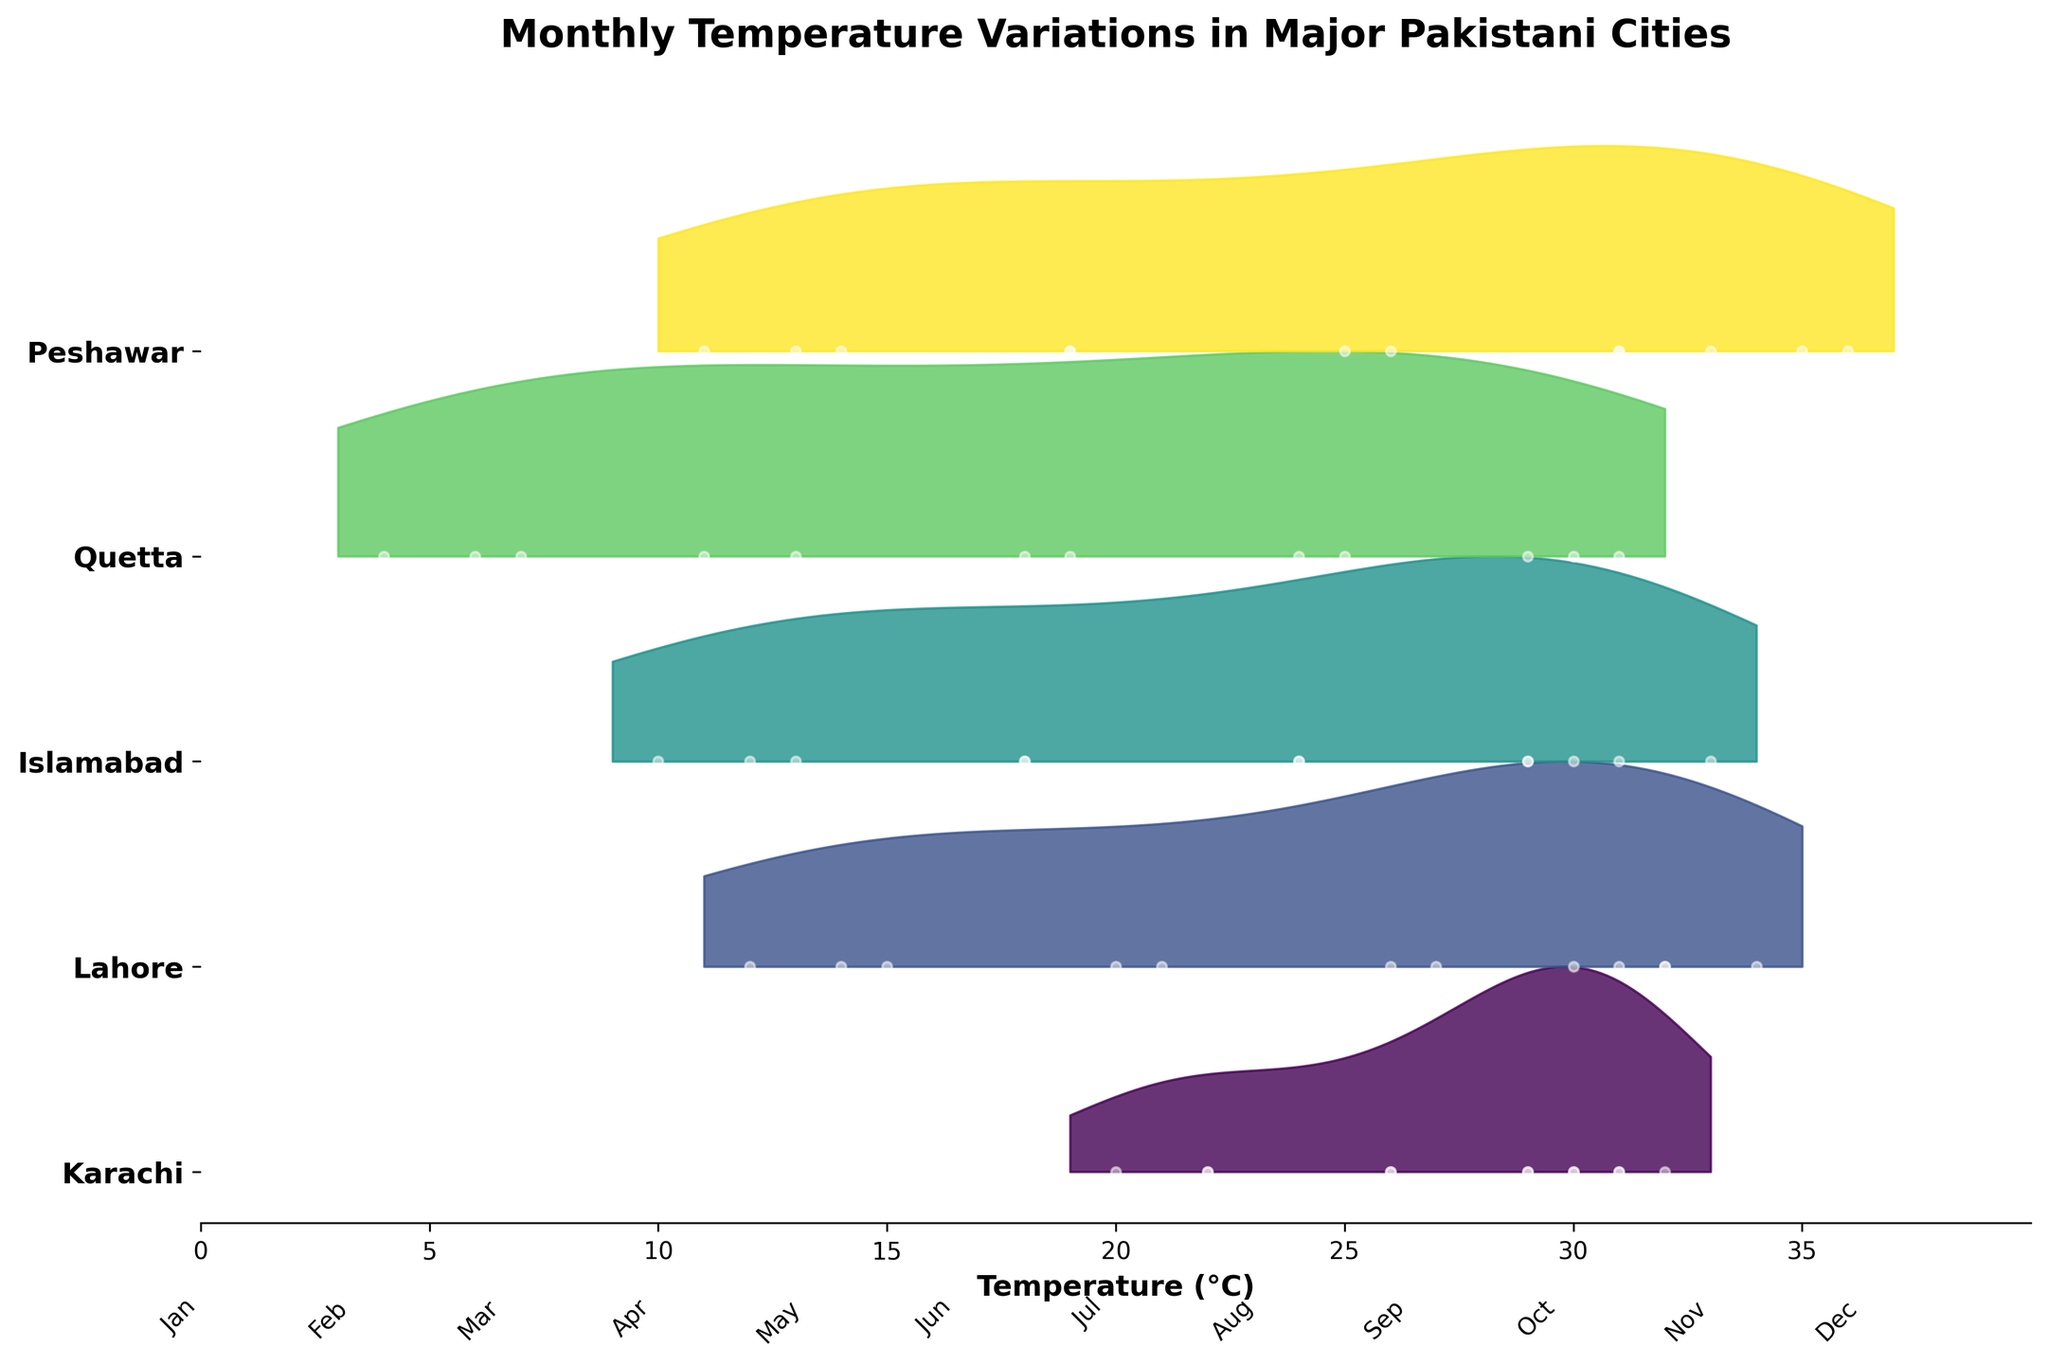What is the highest temperature recorded in Karachi? Identify the peak point on Karachi's line. It is in June with a temperature of 32°C.
Answer: 32°C Which city has the highest temperature in June? Look for the highest peak in June across all cities. Peshawar records the highest temperature at 36°C.
Answer: Peshawar How does the average temperature in July compare between Lahore and Quetta? Look at July's temperatures: Lahore (32°C) and Quetta (31°C). Calculate the average: Lahore (32°C) and Quetta (31°C), so Lahore has a slightly higher average.
Answer: Lahore, higher Which city shows the largest temperature range throughout the year? Calculate the difference between the highest and lowest temperatures for each city. Lahore ranges from 12°C to 34°C, resulting in a range of 22°C, which is the largest.
Answer: Lahore What is the trend of temperatures in Islamabad from January to December? Track the temperature points for Islamabad month by month, starting low at 10°C in January, peaking at 33°C in June, and then dropping back to 12°C in December.
Answer: Rising, peaking in summer, and falling In which month do all cities have relatively similar temperatures? Observe when the density curves overlap or have close values across cities. August shows similar temperatures around 30-31°C.
Answer: August Which city is the coldest in winter (January and December)? Compare temperatures for January and December across cities. Quetta has the lowest temperatures (4°C in January and 6°C in December).
Answer: Quetta What is the temperature range for Peshawar in July? Identify the temperature value for Peshawar in July, which is 35°C. Since it's a single data point, the range is zero, indicating no variation.
Answer: 0°C (no variation) Is there any city whose temperature remains constant over two consecutive months? Look for any flat lines or points that do not change between months. Karachi maintains 30°C from August to September.
Answer: Karachi, August to September 